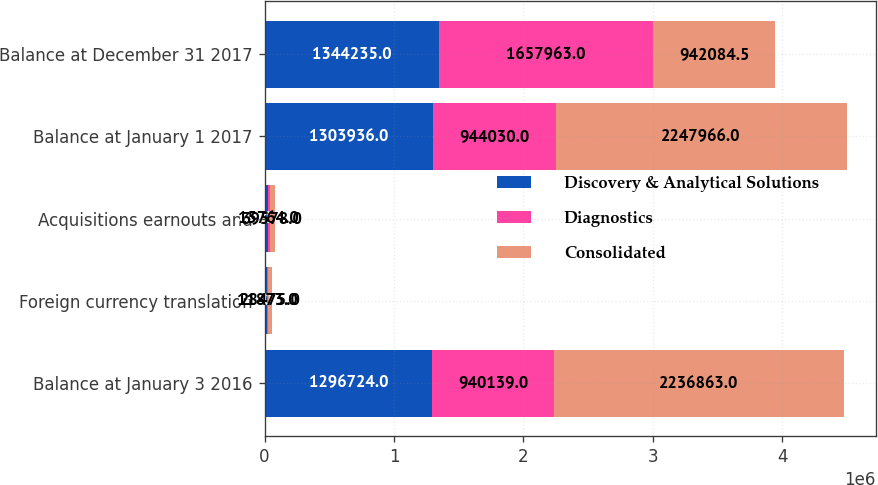<chart> <loc_0><loc_0><loc_500><loc_500><stacked_bar_chart><ecel><fcel>Balance at January 3 2016<fcel>Foreign currency translation<fcel>Acquisitions earnouts and<fcel>Balance at January 1 2017<fcel>Balance at December 31 2017<nl><fcel>Discovery & Analytical Solutions<fcel>1.29672e+06<fcel>16602<fcel>23814<fcel>1.30394e+06<fcel>1.34424e+06<nl><fcel>Diagnostics<fcel>940139<fcel>11873<fcel>15764<fcel>944030<fcel>1.65796e+06<nl><fcel>Consolidated<fcel>2.23686e+06<fcel>28475<fcel>39578<fcel>2.24797e+06<fcel>942084<nl></chart> 